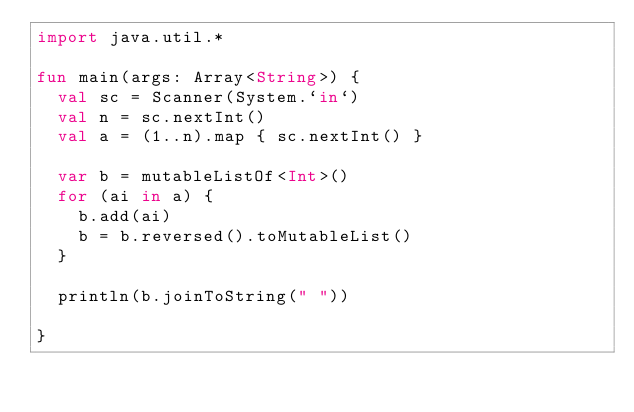<code> <loc_0><loc_0><loc_500><loc_500><_Kotlin_>import java.util.*

fun main(args: Array<String>) {
  val sc = Scanner(System.`in`)
  val n = sc.nextInt()
  val a = (1..n).map { sc.nextInt() }

  var b = mutableListOf<Int>()
  for (ai in a) {
    b.add(ai)
    b = b.reversed().toMutableList()
  }

  println(b.joinToString(" "))

}</code> 